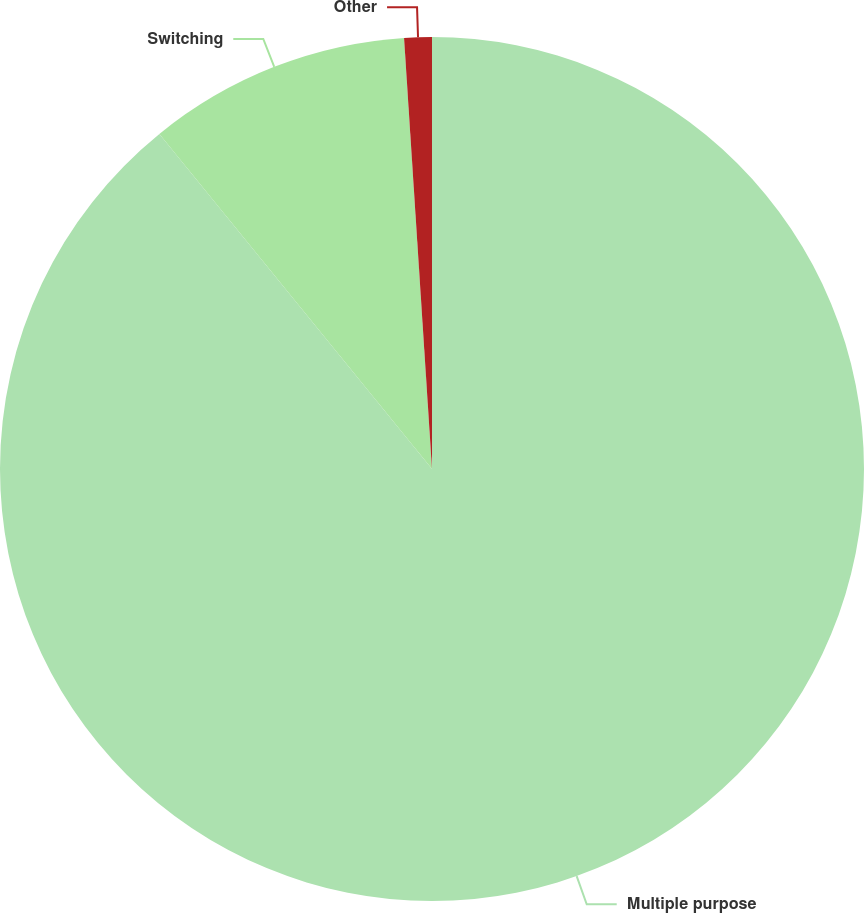Convert chart. <chart><loc_0><loc_0><loc_500><loc_500><pie_chart><fcel>Multiple purpose<fcel>Switching<fcel>Other<nl><fcel>89.13%<fcel>9.84%<fcel>1.03%<nl></chart> 